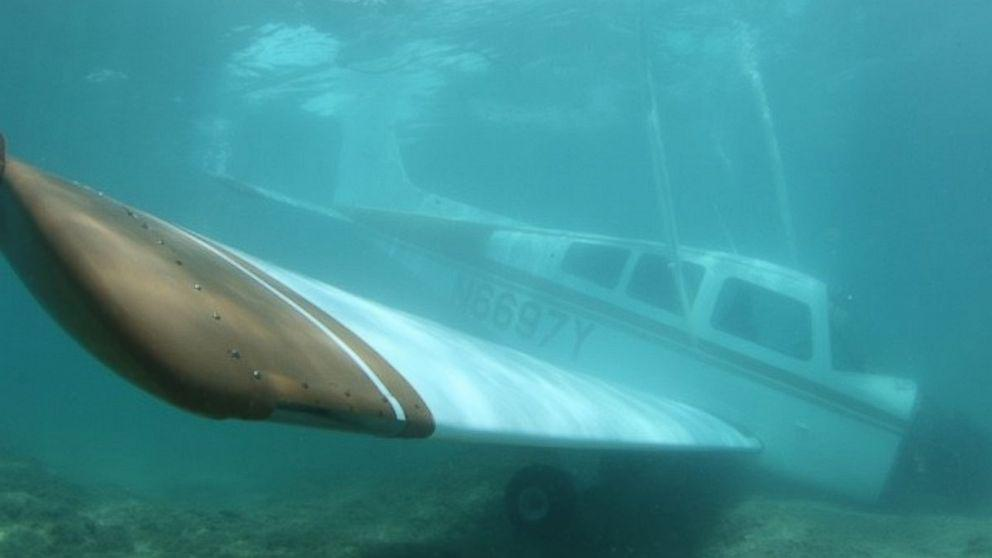Are there any risks to marine life with having an airplane under water? Having an airplane underwater can pose certain risks to marine life, particularly if the plane was not properly prepared before submersion. Potential hazards include leakage of oil, fuel, or other pollutants. However, if the airplane was carefully cleaned and all hazardous materials were removed before sinking, it can actually serve as a stable structure for marine organisms to colonize and can help in forming a new reef ecosystem. 